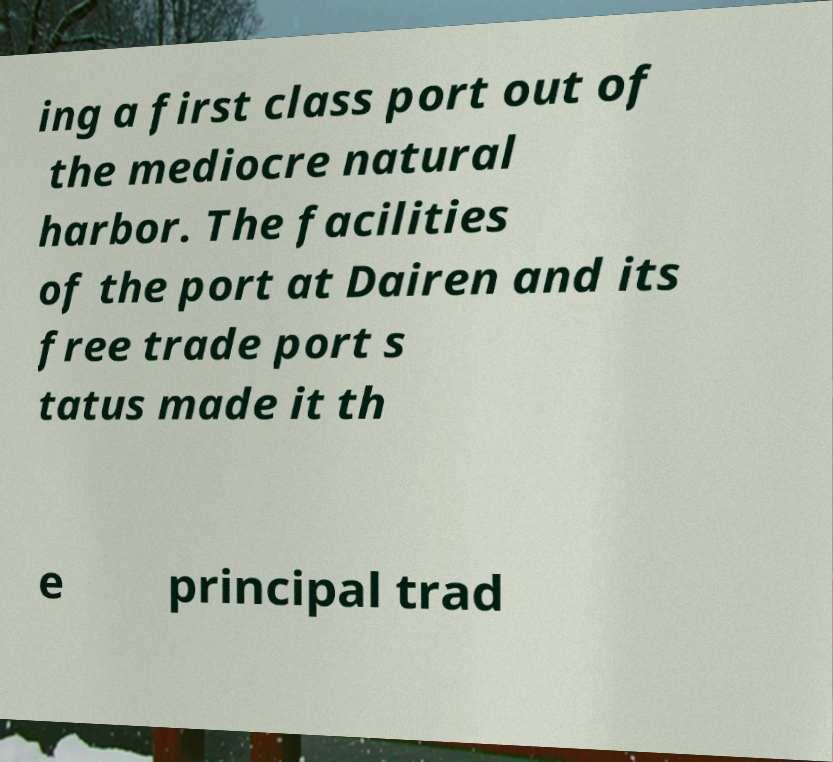Can you read and provide the text displayed in the image?This photo seems to have some interesting text. Can you extract and type it out for me? ing a first class port out of the mediocre natural harbor. The facilities of the port at Dairen and its free trade port s tatus made it th e principal trad 